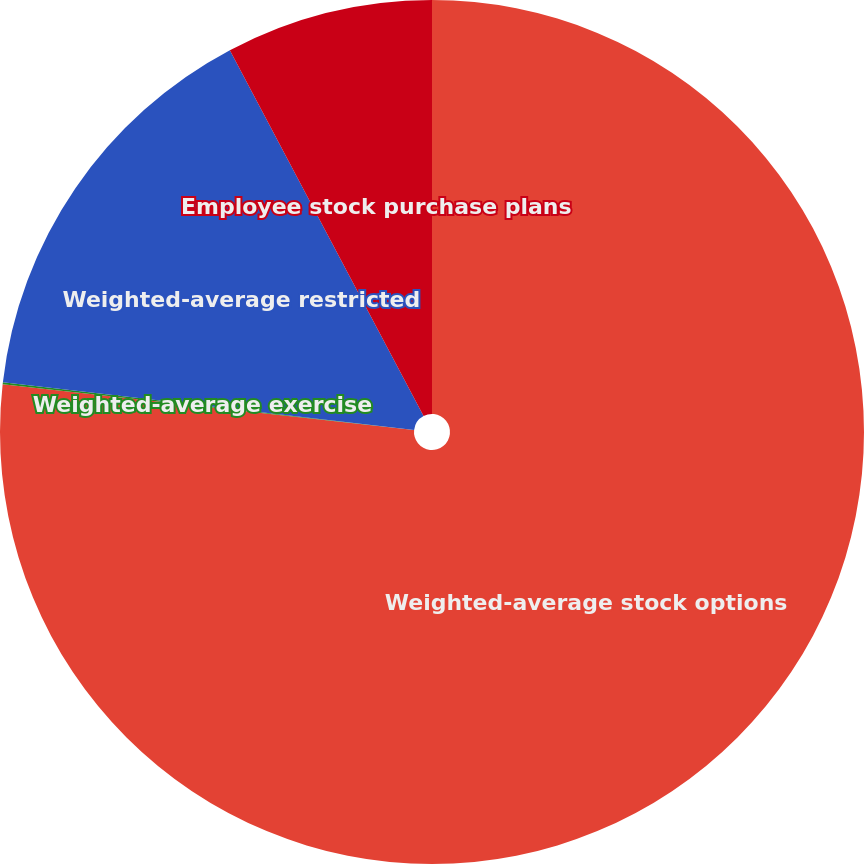<chart> <loc_0><loc_0><loc_500><loc_500><pie_chart><fcel>Weighted-average stock options<fcel>Weighted-average exercise<fcel>Weighted-average restricted<fcel>Employee stock purchase plans<nl><fcel>76.76%<fcel>0.08%<fcel>15.41%<fcel>7.75%<nl></chart> 